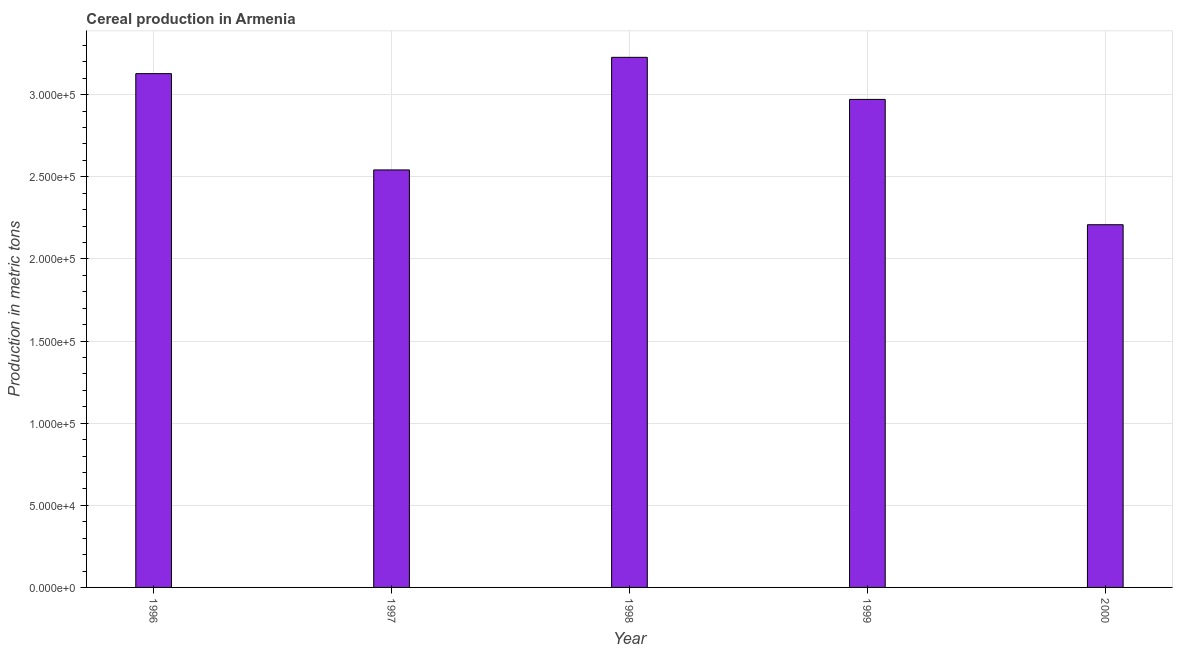Does the graph contain any zero values?
Your response must be concise. No. What is the title of the graph?
Give a very brief answer. Cereal production in Armenia. What is the label or title of the X-axis?
Your answer should be compact. Year. What is the label or title of the Y-axis?
Offer a terse response. Production in metric tons. What is the cereal production in 2000?
Ensure brevity in your answer.  2.21e+05. Across all years, what is the maximum cereal production?
Offer a terse response. 3.23e+05. Across all years, what is the minimum cereal production?
Offer a terse response. 2.21e+05. In which year was the cereal production maximum?
Offer a very short reply. 1998. In which year was the cereal production minimum?
Give a very brief answer. 2000. What is the sum of the cereal production?
Provide a short and direct response. 1.41e+06. What is the difference between the cereal production in 1996 and 1999?
Your answer should be very brief. 1.57e+04. What is the average cereal production per year?
Your answer should be compact. 2.82e+05. What is the median cereal production?
Make the answer very short. 2.97e+05. In how many years, is the cereal production greater than 280000 metric tons?
Give a very brief answer. 3. What is the ratio of the cereal production in 1996 to that in 2000?
Provide a succinct answer. 1.42. Is the cereal production in 1998 less than that in 2000?
Provide a short and direct response. No. What is the difference between the highest and the second highest cereal production?
Give a very brief answer. 9930. Is the sum of the cereal production in 1997 and 1998 greater than the maximum cereal production across all years?
Your answer should be compact. Yes. What is the difference between the highest and the lowest cereal production?
Your response must be concise. 1.02e+05. In how many years, is the cereal production greater than the average cereal production taken over all years?
Ensure brevity in your answer.  3. How many bars are there?
Offer a very short reply. 5. Are all the bars in the graph horizontal?
Keep it short and to the point. No. How many years are there in the graph?
Provide a short and direct response. 5. Are the values on the major ticks of Y-axis written in scientific E-notation?
Ensure brevity in your answer.  Yes. What is the Production in metric tons of 1996?
Provide a short and direct response. 3.13e+05. What is the Production in metric tons in 1997?
Your answer should be very brief. 2.54e+05. What is the Production in metric tons in 1998?
Ensure brevity in your answer.  3.23e+05. What is the Production in metric tons in 1999?
Your answer should be compact. 2.97e+05. What is the Production in metric tons in 2000?
Offer a terse response. 2.21e+05. What is the difference between the Production in metric tons in 1996 and 1997?
Provide a succinct answer. 5.86e+04. What is the difference between the Production in metric tons in 1996 and 1998?
Ensure brevity in your answer.  -9930. What is the difference between the Production in metric tons in 1996 and 1999?
Your response must be concise. 1.57e+04. What is the difference between the Production in metric tons in 1996 and 2000?
Keep it short and to the point. 9.20e+04. What is the difference between the Production in metric tons in 1997 and 1998?
Keep it short and to the point. -6.86e+04. What is the difference between the Production in metric tons in 1997 and 1999?
Your answer should be compact. -4.29e+04. What is the difference between the Production in metric tons in 1997 and 2000?
Provide a short and direct response. 3.34e+04. What is the difference between the Production in metric tons in 1998 and 1999?
Offer a terse response. 2.56e+04. What is the difference between the Production in metric tons in 1998 and 2000?
Give a very brief answer. 1.02e+05. What is the difference between the Production in metric tons in 1999 and 2000?
Offer a terse response. 7.63e+04. What is the ratio of the Production in metric tons in 1996 to that in 1997?
Make the answer very short. 1.23. What is the ratio of the Production in metric tons in 1996 to that in 1998?
Keep it short and to the point. 0.97. What is the ratio of the Production in metric tons in 1996 to that in 1999?
Your response must be concise. 1.05. What is the ratio of the Production in metric tons in 1996 to that in 2000?
Give a very brief answer. 1.42. What is the ratio of the Production in metric tons in 1997 to that in 1998?
Keep it short and to the point. 0.79. What is the ratio of the Production in metric tons in 1997 to that in 1999?
Ensure brevity in your answer.  0.86. What is the ratio of the Production in metric tons in 1997 to that in 2000?
Provide a short and direct response. 1.15. What is the ratio of the Production in metric tons in 1998 to that in 1999?
Give a very brief answer. 1.09. What is the ratio of the Production in metric tons in 1998 to that in 2000?
Make the answer very short. 1.46. What is the ratio of the Production in metric tons in 1999 to that in 2000?
Your response must be concise. 1.34. 